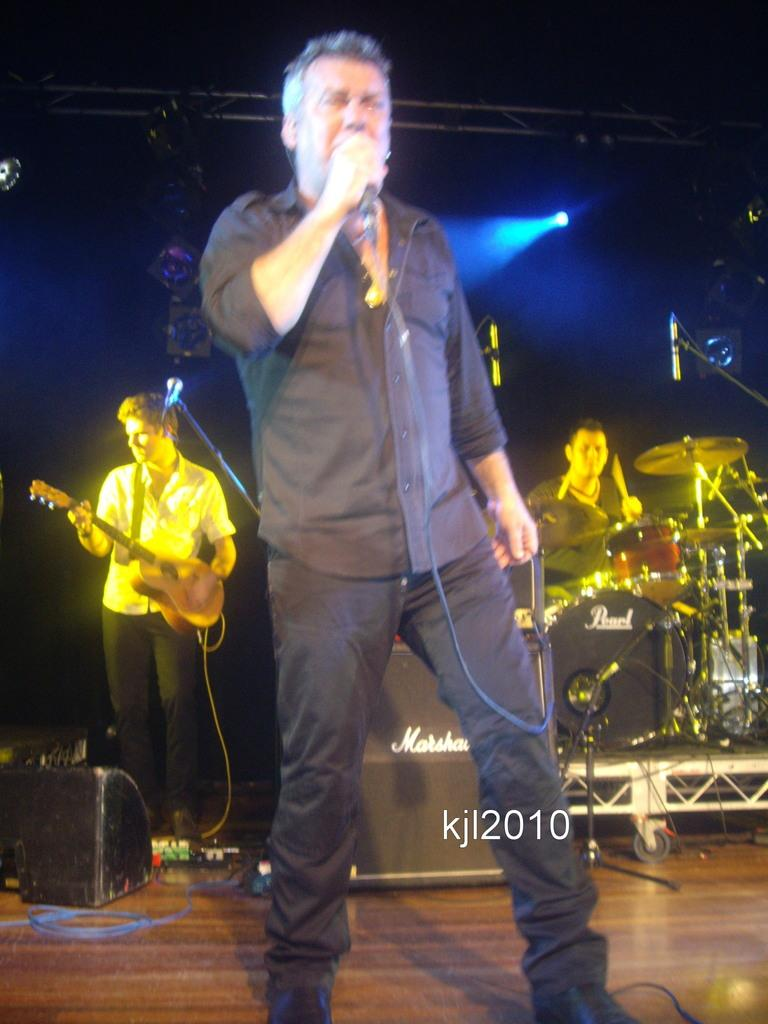How many people are on the stage in the image? There are three persons standing on a stage in the image. What are the people on the stage doing? The persons are playing musical instruments, and the person in the center is singing a song. Can you describe the position of the person in the center? The person in the center is standing in the middle of the stage. What can be seen in the background of the image? There are lights visible in the background. What type of scarf is the person in the center wearing in the image? There is no scarf visible on the person in the center in the image. Can you tell me how many flowers are in the garden behind the stage? There is no garden present in the image; it features a stage with three persons and lights in the background. 